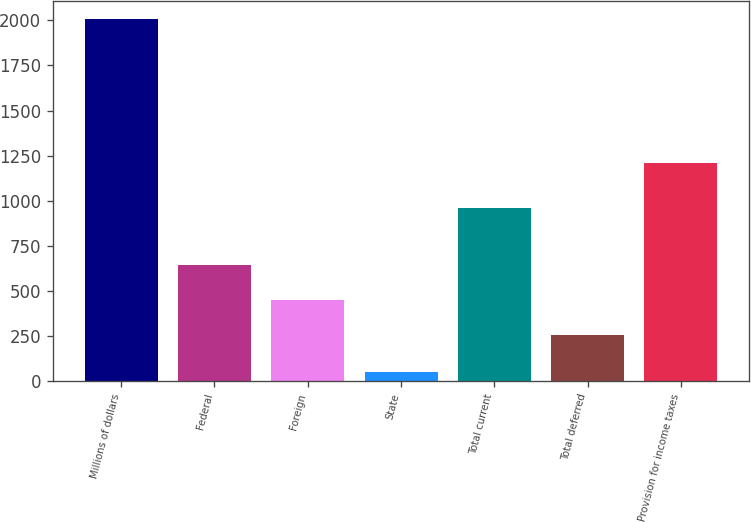Convert chart. <chart><loc_0><loc_0><loc_500><loc_500><bar_chart><fcel>Millions of dollars<fcel>Federal<fcel>Foreign<fcel>State<fcel>Total current<fcel>Total deferred<fcel>Provision for income taxes<nl><fcel>2008<fcel>645.6<fcel>449.8<fcel>50<fcel>957<fcel>254<fcel>1211<nl></chart> 